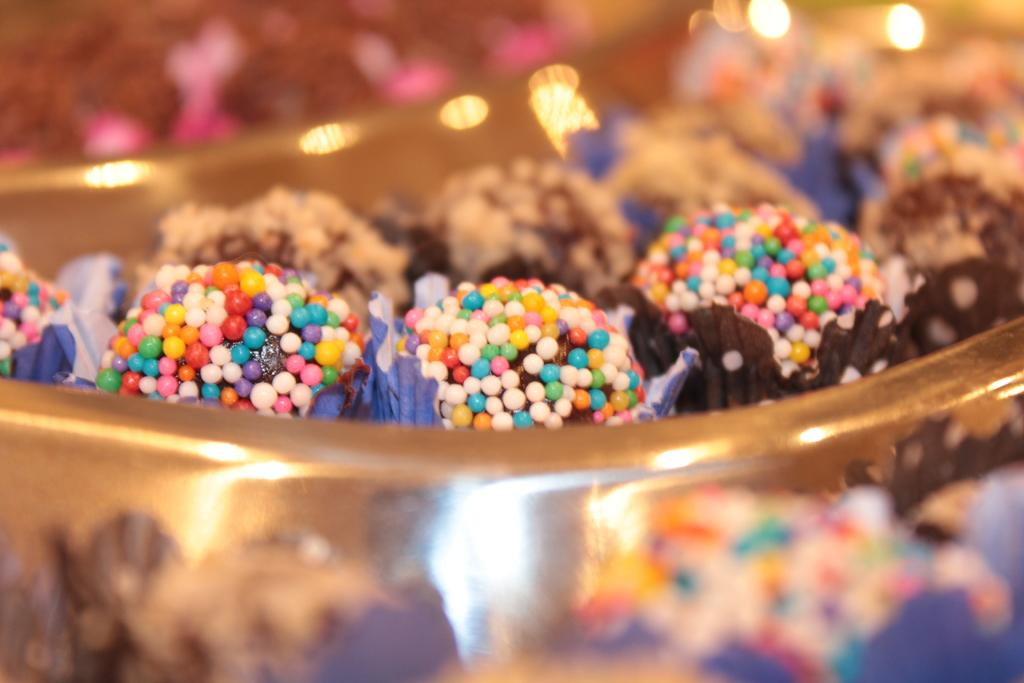What is in the bowl that is visible in the image? There is a bowl containing desserts in the image. Can you tell me how many lamps are visible in the image? There is no lamp present in the image; it only features a bowl containing desserts. What type of shoes can be seen on the desserts in the image? There are no shoes present in the image, as it only features a bowl containing desserts. 